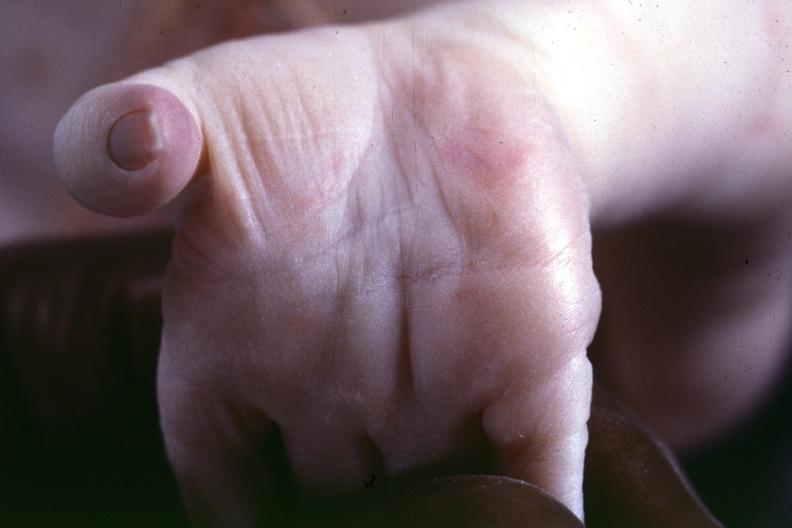re extremities present?
Answer the question using a single word or phrase. Yes 